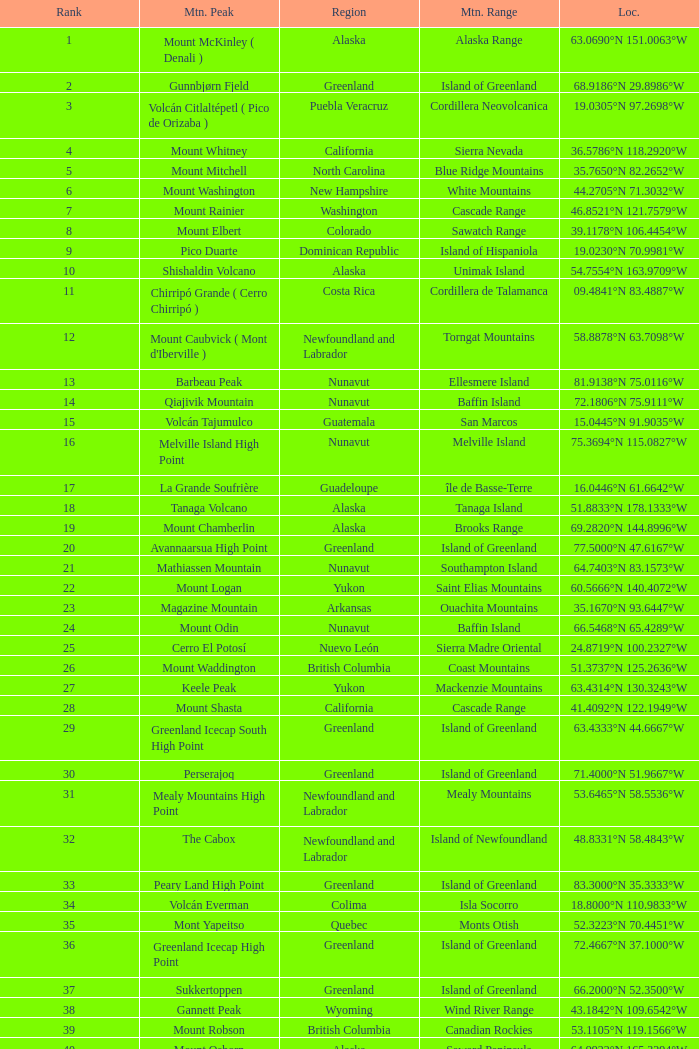Which mountain top is located in the baja california zone and has a position of 2 Isla Cedros High Point. 